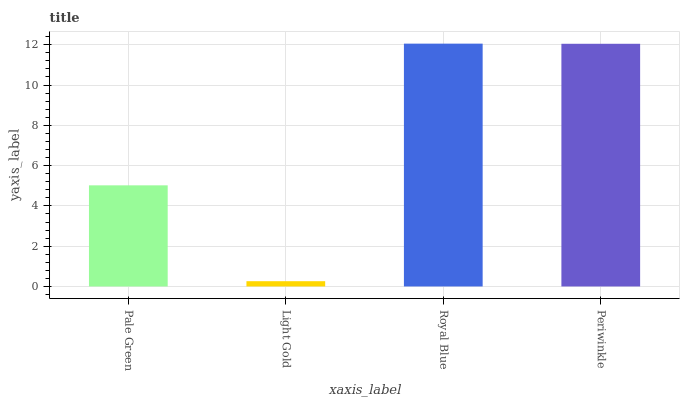Is Light Gold the minimum?
Answer yes or no. Yes. Is Royal Blue the maximum?
Answer yes or no. Yes. Is Royal Blue the minimum?
Answer yes or no. No. Is Light Gold the maximum?
Answer yes or no. No. Is Royal Blue greater than Light Gold?
Answer yes or no. Yes. Is Light Gold less than Royal Blue?
Answer yes or no. Yes. Is Light Gold greater than Royal Blue?
Answer yes or no. No. Is Royal Blue less than Light Gold?
Answer yes or no. No. Is Periwinkle the high median?
Answer yes or no. Yes. Is Pale Green the low median?
Answer yes or no. Yes. Is Royal Blue the high median?
Answer yes or no. No. Is Royal Blue the low median?
Answer yes or no. No. 